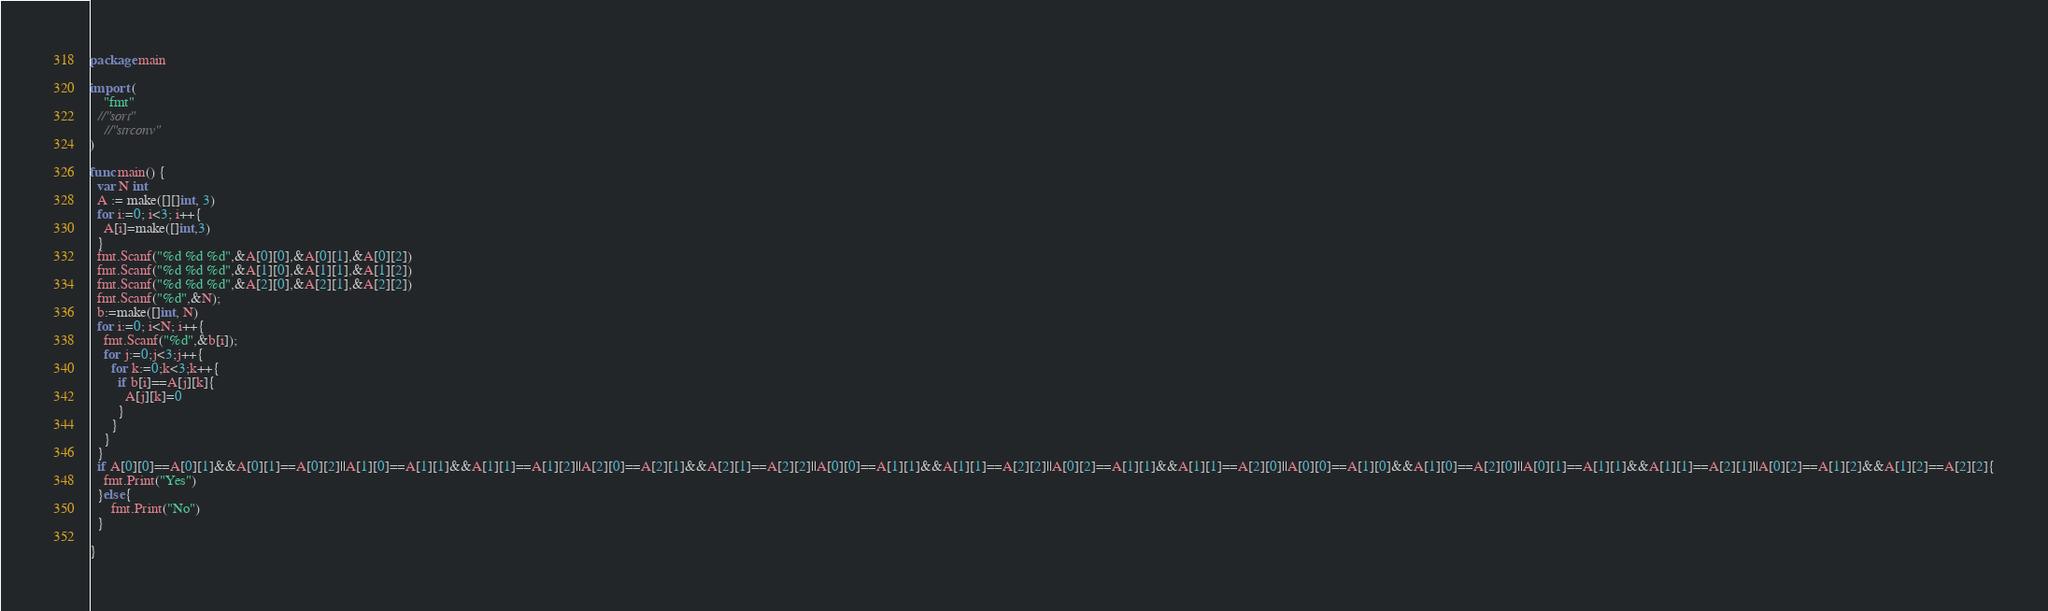Convert code to text. <code><loc_0><loc_0><loc_500><loc_500><_Go_>package main

import (
	"fmt"
  //"sort"
	//"strconv"
)

func main() {
  var N int
  A := make([][]int, 3)
  for i:=0; i<3; i++{
    A[i]=make([]int,3)
  }
  fmt.Scanf("%d %d %d",&A[0][0],&A[0][1],&A[0][2])
  fmt.Scanf("%d %d %d",&A[1][0],&A[1][1],&A[1][2])
  fmt.Scanf("%d %d %d",&A[2][0],&A[2][1],&A[2][2])
  fmt.Scanf("%d",&N);
  b:=make([]int, N)
  for i:=0; i<N; i++{
    fmt.Scanf("%d",&b[i]);
    for j:=0;j<3;j++{
      for k:=0;k<3;k++{
        if b[i]==A[j][k]{
          A[j][k]=0
        }
      }
    }
  }
  if A[0][0]==A[0][1]&&A[0][1]==A[0][2]||A[1][0]==A[1][1]&&A[1][1]==A[1][2]||A[2][0]==A[2][1]&&A[2][1]==A[2][2]||A[0][0]==A[1][1]&&A[1][1]==A[2][2]||A[0][2]==A[1][1]&&A[1][1]==A[2][0]||A[0][0]==A[1][0]&&A[1][0]==A[2][0]||A[0][1]==A[1][1]&&A[1][1]==A[2][1]||A[0][2]==A[1][2]&&A[1][2]==A[2][2]{
    fmt.Print("Yes")
  }else{
      fmt.Print("No")
  }

}</code> 